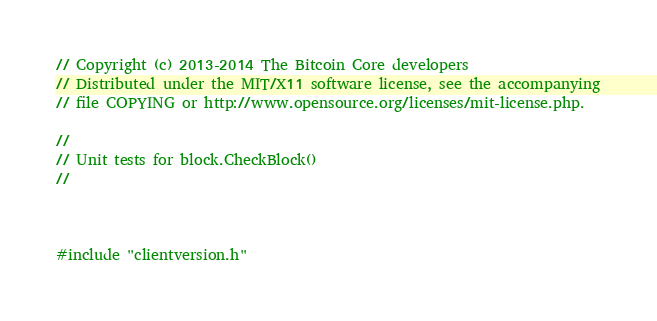<code> <loc_0><loc_0><loc_500><loc_500><_C++_>// Copyright (c) 2013-2014 The Bitcoin Core developers
// Distributed under the MIT/X11 software license, see the accompanying
// file COPYING or http://www.opensource.org/licenses/mit-license.php.

//
// Unit tests for block.CheckBlock()
//



#include "clientversion.h"</code> 